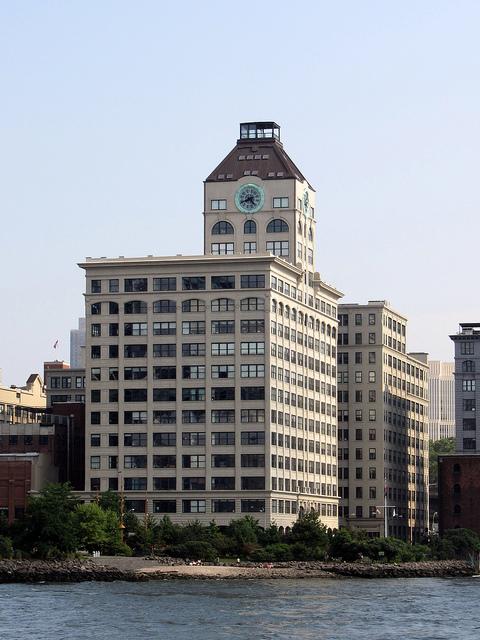Is there an obelisk?
Quick response, please. No. Is the sky clear?
Concise answer only. Yes. How many boats on the water?
Quick response, please. 0. What time is it?
Write a very short answer. 5:40. How deep is the water?
Answer briefly. Deep. What is the time of day?
Concise answer only. 5:40. What is the building in the background?
Write a very short answer. Office. Is there a clock on the building?
Give a very brief answer. Yes. Does the building only have windows?
Short answer required. No. Is it raining in this picture?
Keep it brief. No. Is the building brown and tan?
Be succinct. Yes. 